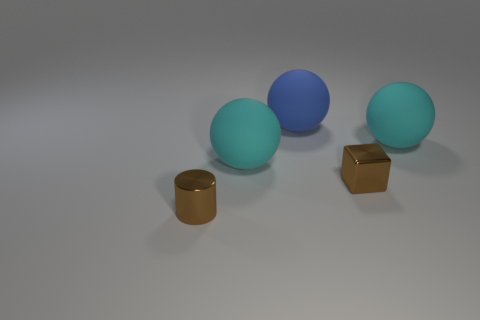Add 3 gray balls. How many objects exist? 8 Subtract all blocks. How many objects are left? 4 Subtract 0 purple blocks. How many objects are left? 5 Subtract all metal objects. Subtract all cyan spheres. How many objects are left? 1 Add 2 tiny brown things. How many tiny brown things are left? 4 Add 1 shiny cylinders. How many shiny cylinders exist? 2 